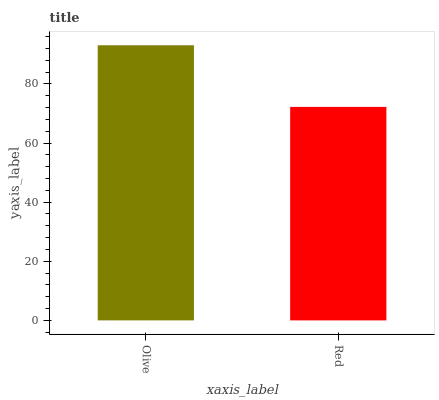Is Red the minimum?
Answer yes or no. Yes. Is Olive the maximum?
Answer yes or no. Yes. Is Red the maximum?
Answer yes or no. No. Is Olive greater than Red?
Answer yes or no. Yes. Is Red less than Olive?
Answer yes or no. Yes. Is Red greater than Olive?
Answer yes or no. No. Is Olive less than Red?
Answer yes or no. No. Is Olive the high median?
Answer yes or no. Yes. Is Red the low median?
Answer yes or no. Yes. Is Red the high median?
Answer yes or no. No. Is Olive the low median?
Answer yes or no. No. 